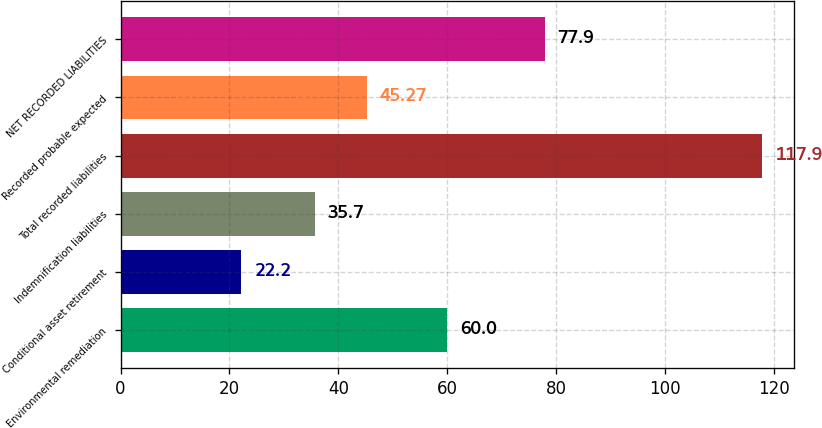<chart> <loc_0><loc_0><loc_500><loc_500><bar_chart><fcel>Environmental remediation<fcel>Conditional asset retirement<fcel>Indemnification liabilities<fcel>Total recorded liabilities<fcel>Recorded probable expected<fcel>NET RECORDED LIABILITIES<nl><fcel>60<fcel>22.2<fcel>35.7<fcel>117.9<fcel>45.27<fcel>77.9<nl></chart> 